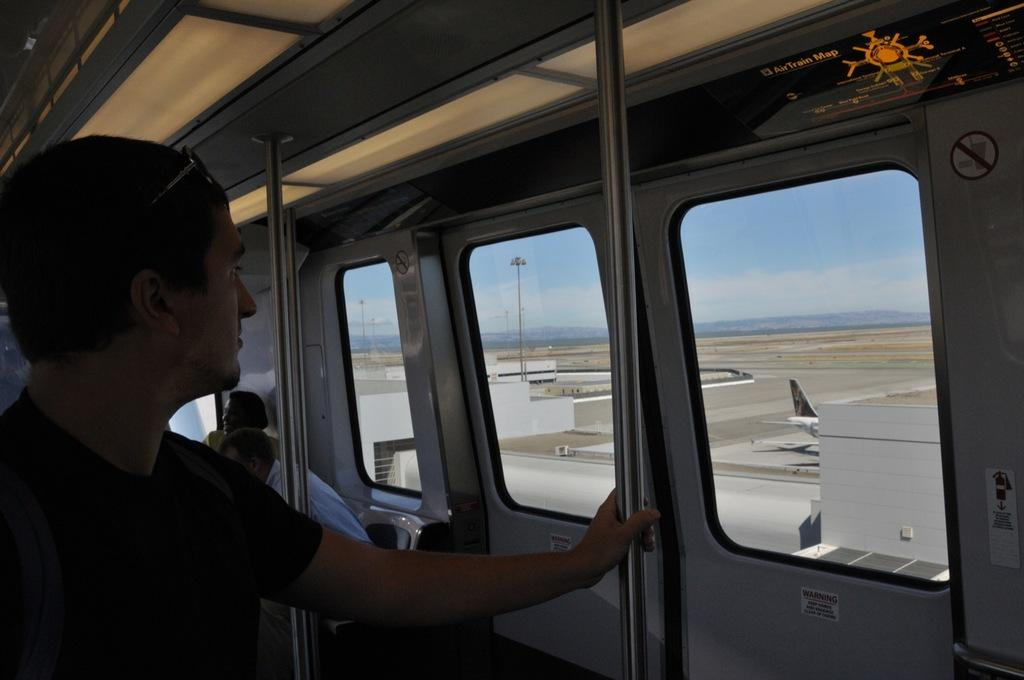What is the main subject of the image? There is a person standing in the image. Can you describe the surroundings of the person? There are other people in the train and a runway in the image. What else can be seen in the image? There is an airplane in the image. What type of stem is being taught by the person in the image? There is no indication of teaching or any stem-related activity in the image. What kind of cheese is being served to the people in the train? There is no cheese present in the image. 